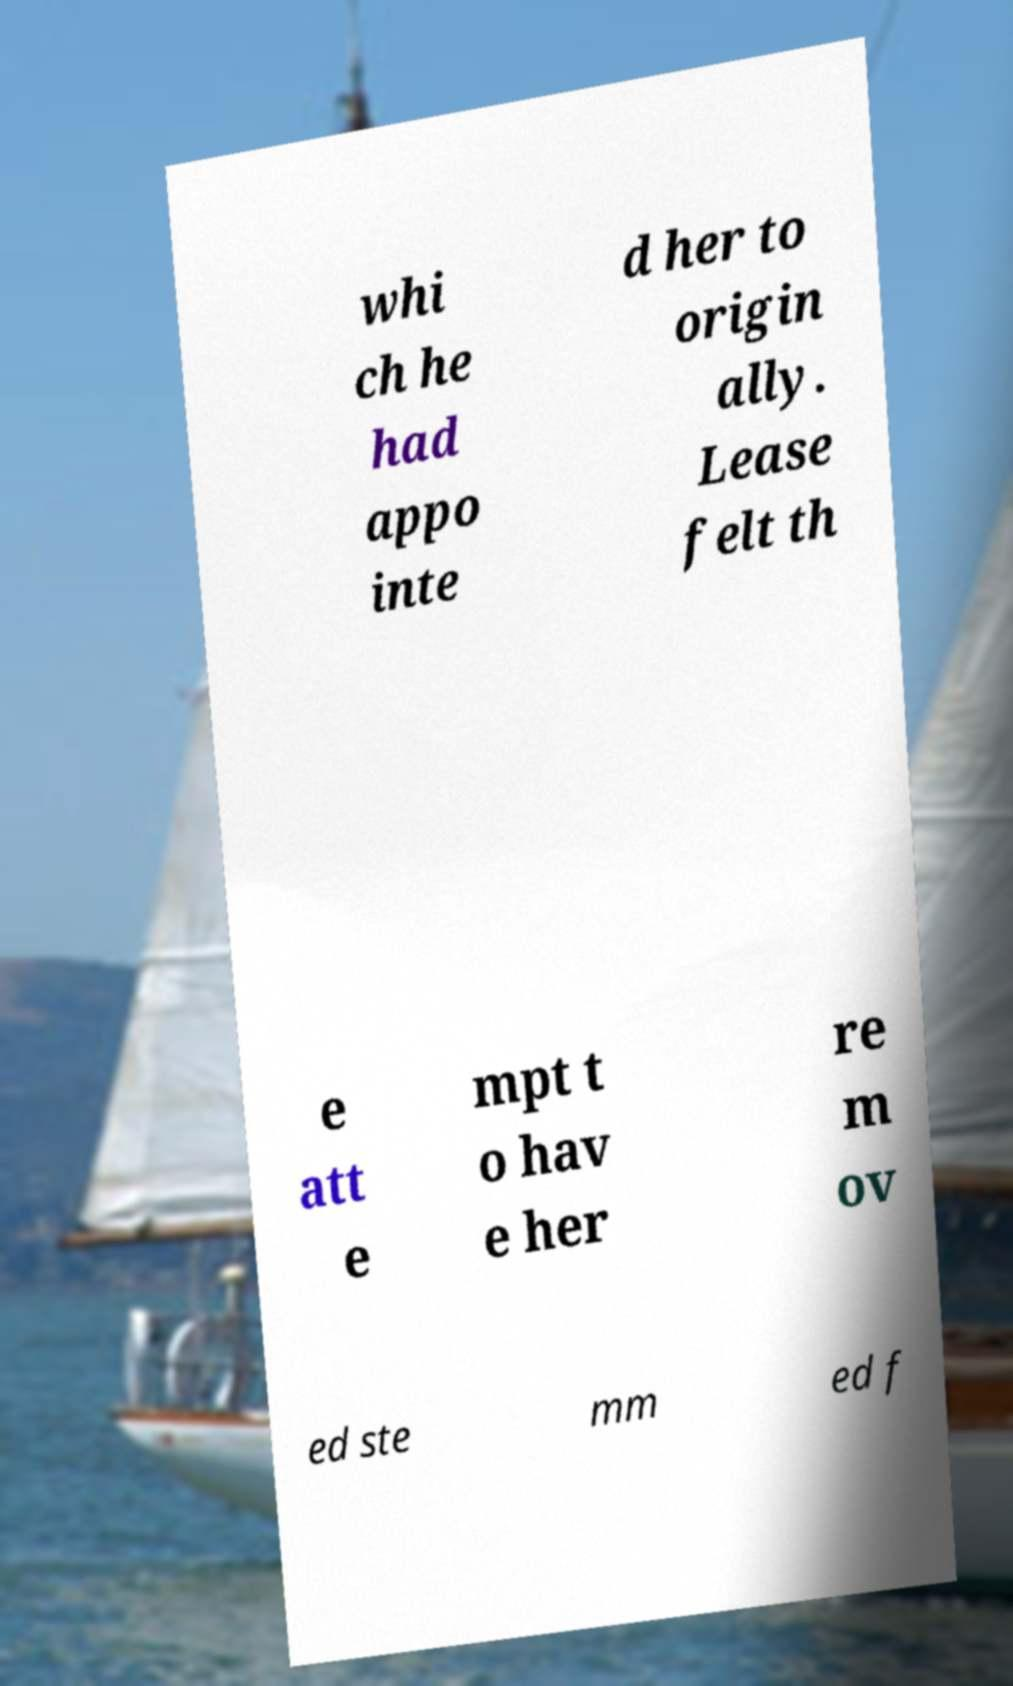I need the written content from this picture converted into text. Can you do that? whi ch he had appo inte d her to origin ally. Lease felt th e att e mpt t o hav e her re m ov ed ste mm ed f 